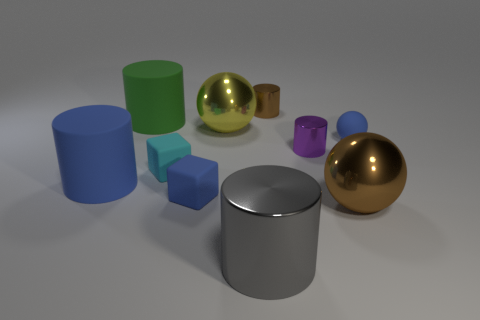There is a small block that is the same color as the tiny ball; what material is it?
Keep it short and to the point. Rubber. There is a brown shiny object behind the matte cylinder that is behind the tiny purple thing; how many shiny balls are to the right of it?
Offer a very short reply. 1. What number of brown things are large matte things or metallic spheres?
Your answer should be compact. 1. What is the color of the sphere that is the same material as the small cyan thing?
Provide a short and direct response. Blue. What number of big things are either gray matte cylinders or matte things?
Your answer should be very brief. 2. Are there fewer blue cylinders than tiny brown matte cylinders?
Make the answer very short. No. What color is the other matte object that is the same shape as the small cyan rubber thing?
Your answer should be compact. Blue. Is there anything else that is the same shape as the big yellow shiny object?
Your answer should be compact. Yes. Are there more tiny blue things than gray cylinders?
Provide a short and direct response. Yes. How many other objects are there of the same material as the large brown thing?
Make the answer very short. 4. 